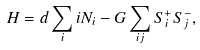Convert formula to latex. <formula><loc_0><loc_0><loc_500><loc_500>H = d \sum _ { i } i N _ { i } - G \sum _ { i j } S ^ { + } _ { i } S ^ { - } _ { j } ,</formula> 